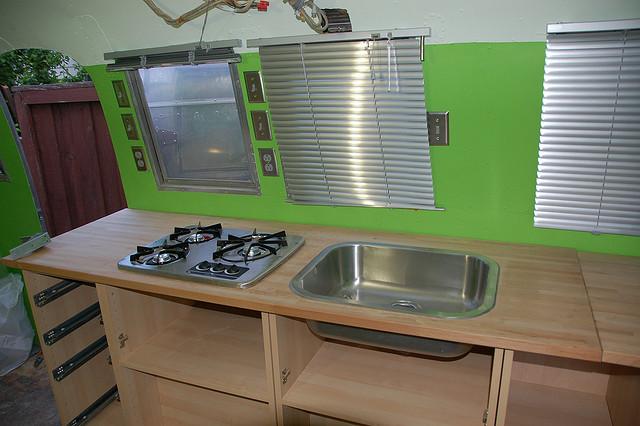What color are the walls?
Give a very brief answer. Green. What color is the wood?
Quick response, please. Brown. What color is the wall?
Be succinct. Green. What is required in order to be able to use this equipment?
Short answer required. Water. What are the blinds made of?
Keep it brief. Metal. 